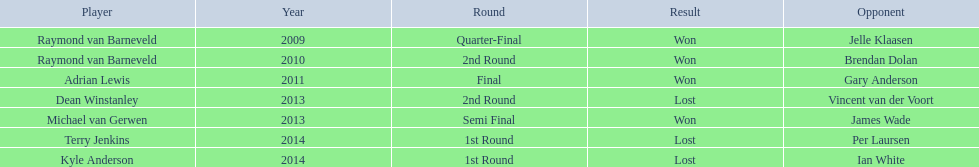Which players are mentioned? Raymond van Barneveld, Raymond van Barneveld, Adrian Lewis, Dean Winstanley, Michael van Gerwen, Terry Jenkins, Kyle Anderson. Among them, who participated in 2011? Adrian Lewis. 